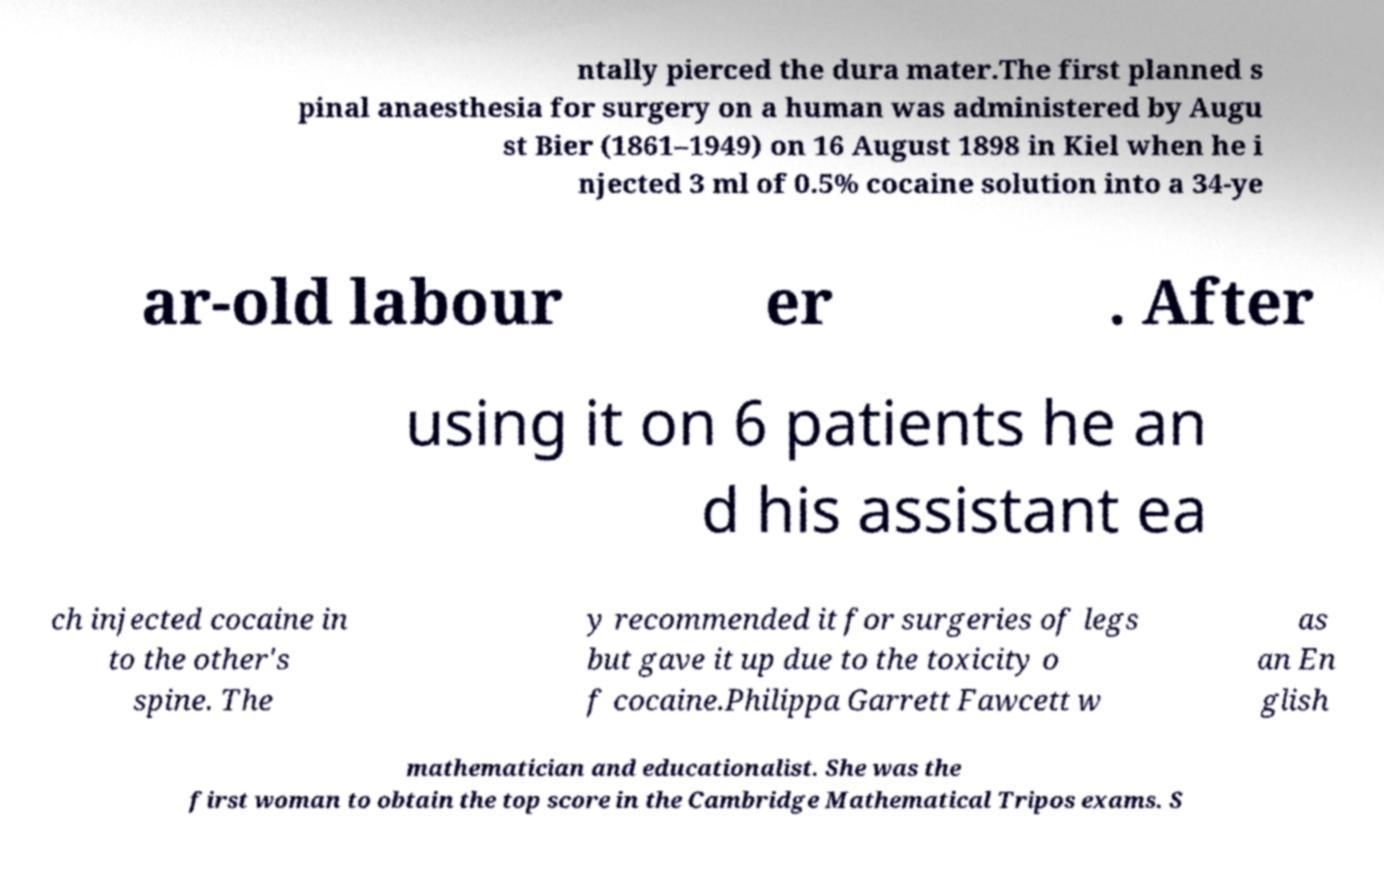Can you read and provide the text displayed in the image?This photo seems to have some interesting text. Can you extract and type it out for me? ntally pierced the dura mater.The first planned s pinal anaesthesia for surgery on a human was administered by Augu st Bier (1861–1949) on 16 August 1898 in Kiel when he i njected 3 ml of 0.5% cocaine solution into a 34-ye ar-old labour er . After using it on 6 patients he an d his assistant ea ch injected cocaine in to the other's spine. The y recommended it for surgeries of legs but gave it up due to the toxicity o f cocaine.Philippa Garrett Fawcett w as an En glish mathematician and educationalist. She was the first woman to obtain the top score in the Cambridge Mathematical Tripos exams. S 